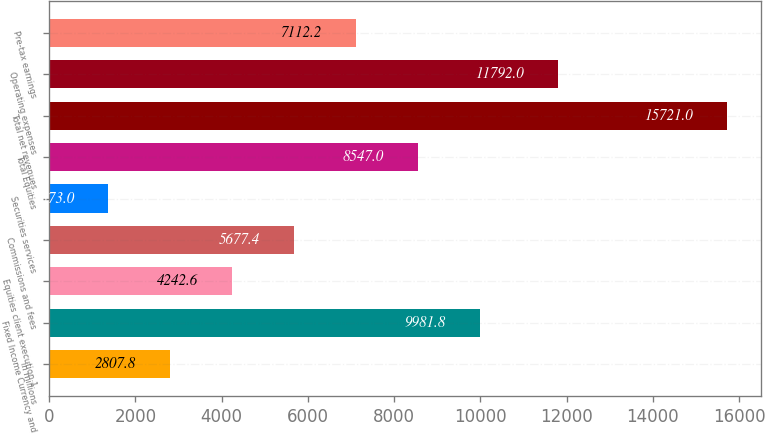Convert chart to OTSL. <chart><loc_0><loc_0><loc_500><loc_500><bar_chart><fcel>in millions<fcel>Fixed Income Currency and<fcel>Equities client execution 1<fcel>Commissions and fees<fcel>Securities services<fcel>Total Equities<fcel>Total net revenues<fcel>Operating expenses<fcel>Pre-tax earnings<nl><fcel>2807.8<fcel>9981.8<fcel>4242.6<fcel>5677.4<fcel>1373<fcel>8547<fcel>15721<fcel>11792<fcel>7112.2<nl></chart> 